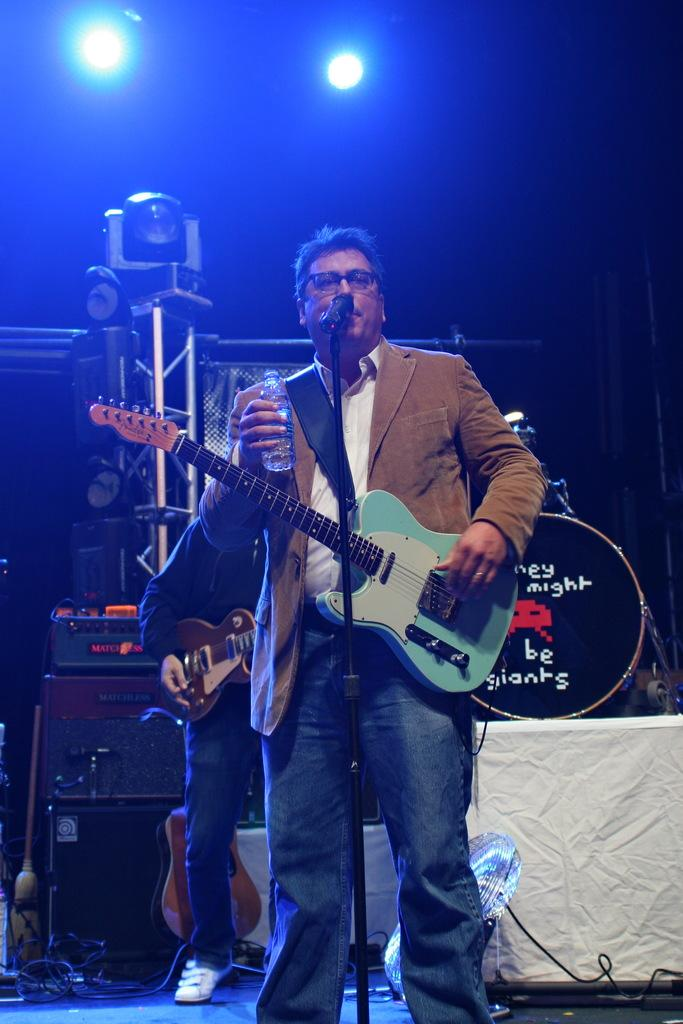What is the man in the image doing? The man is playing a guitar. What is the man positioned near in the image? The man is in front of a microphone. Where is the man located in the image? The man is on a stage. What else can be seen in the image related to music? There are musical instruments in the background of the image. Can you see any mice or rice on the stage in the image? No, there are no mice or rice present on the stage in the image. 